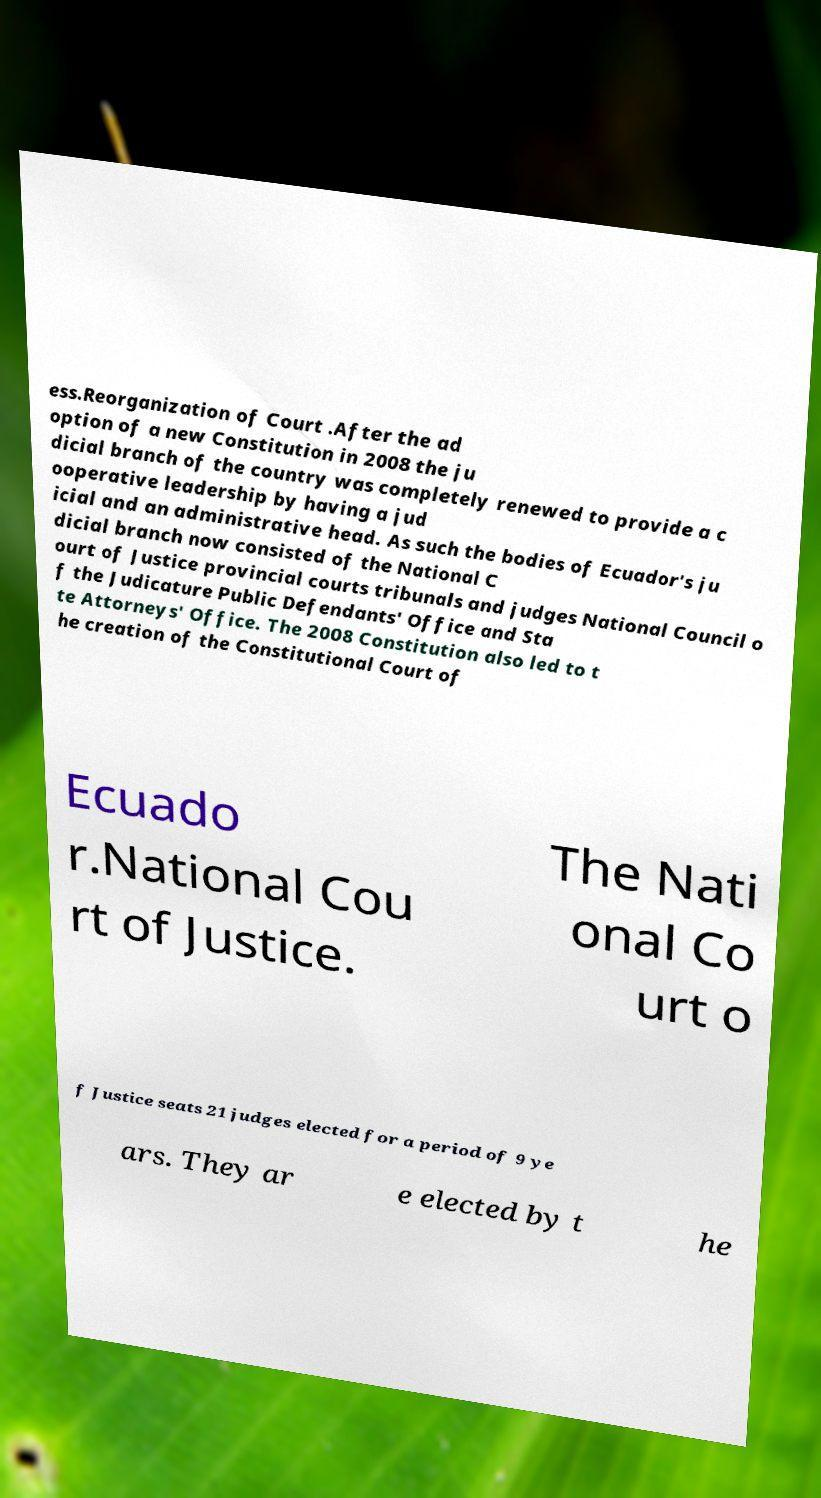For documentation purposes, I need the text within this image transcribed. Could you provide that? ess.Reorganization of Court .After the ad option of a new Constitution in 2008 the ju dicial branch of the country was completely renewed to provide a c ooperative leadership by having a jud icial and an administrative head. As such the bodies of Ecuador's ju dicial branch now consisted of the National C ourt of Justice provincial courts tribunals and judges National Council o f the Judicature Public Defendants' Office and Sta te Attorneys' Office. The 2008 Constitution also led to t he creation of the Constitutional Court of Ecuado r.National Cou rt of Justice. The Nati onal Co urt o f Justice seats 21 judges elected for a period of 9 ye ars. They ar e elected by t he 